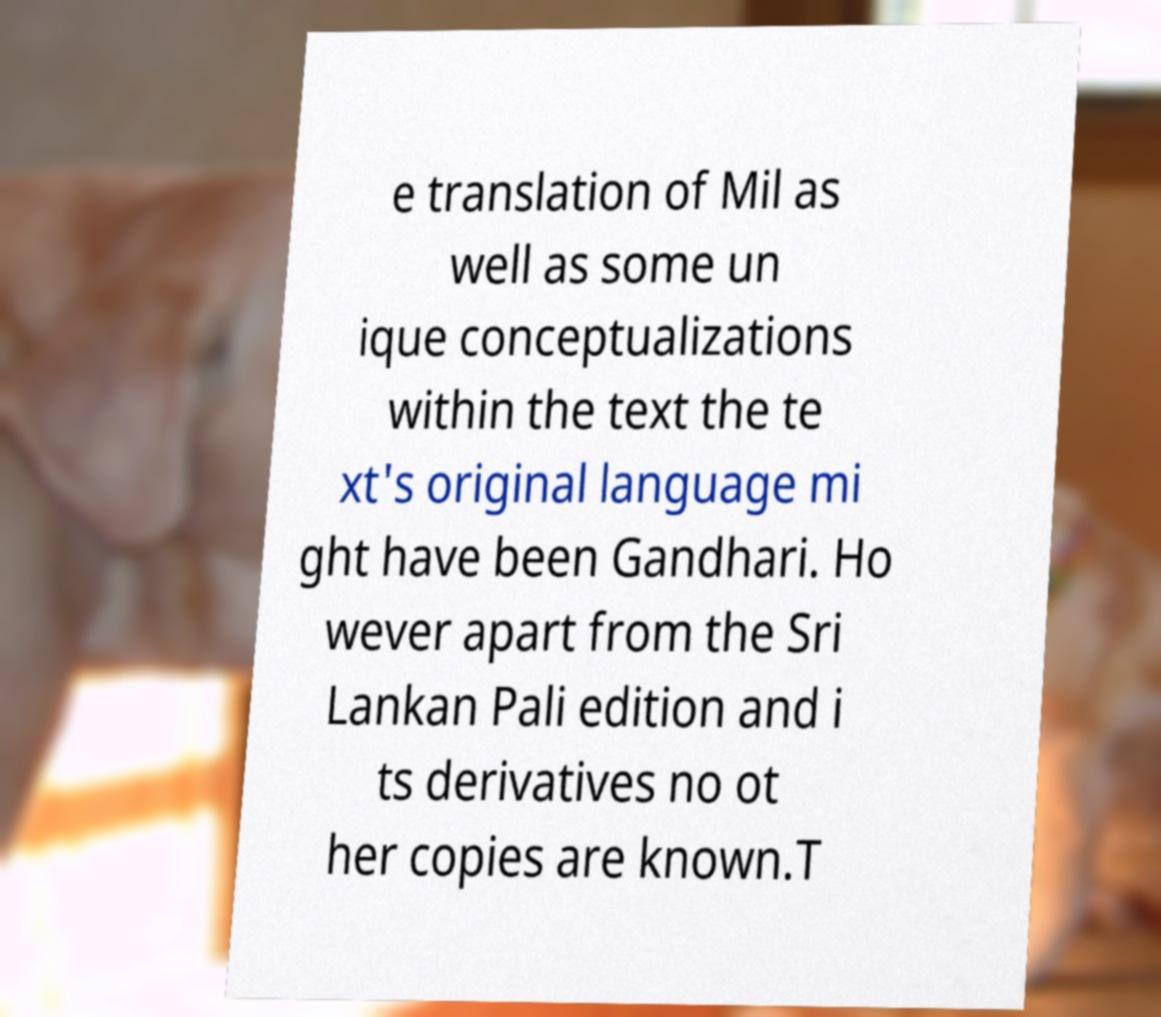Could you assist in decoding the text presented in this image and type it out clearly? e translation of Mil as well as some un ique conceptualizations within the text the te xt's original language mi ght have been Gandhari. Ho wever apart from the Sri Lankan Pali edition and i ts derivatives no ot her copies are known.T 